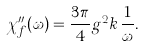Convert formula to latex. <formula><loc_0><loc_0><loc_500><loc_500>\chi _ { f } ^ { \prime \prime } ( \omega ) = \frac { 3 \pi } { 4 } g ^ { 2 } k \, \frac { 1 } { \omega } .</formula> 